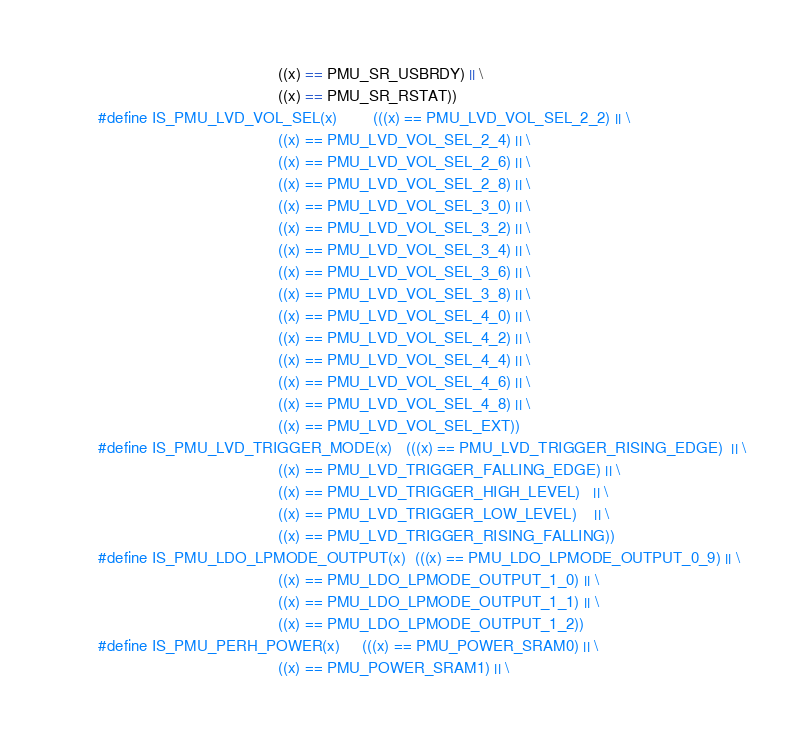Convert code to text. <code><loc_0><loc_0><loc_500><loc_500><_C_>                                         ((x) == PMU_SR_USBRDY) || \
                                         ((x) == PMU_SR_RSTAT))
#define IS_PMU_LVD_VOL_SEL(x)		(((x) == PMU_LVD_VOL_SEL_2_2) || \
                                         ((x) == PMU_LVD_VOL_SEL_2_4) || \
                                         ((x) == PMU_LVD_VOL_SEL_2_6) || \
                                         ((x) == PMU_LVD_VOL_SEL_2_8) || \
                                         ((x) == PMU_LVD_VOL_SEL_3_0) || \
                                         ((x) == PMU_LVD_VOL_SEL_3_2) || \
                                         ((x) == PMU_LVD_VOL_SEL_3_4) || \
                                         ((x) == PMU_LVD_VOL_SEL_3_6) || \
                                         ((x) == PMU_LVD_VOL_SEL_3_8) || \
                                         ((x) == PMU_LVD_VOL_SEL_4_0) || \
                                         ((x) == PMU_LVD_VOL_SEL_4_2) || \
                                         ((x) == PMU_LVD_VOL_SEL_4_4) || \
                                         ((x) == PMU_LVD_VOL_SEL_4_6) || \
                                         ((x) == PMU_LVD_VOL_SEL_4_8) || \
                                         ((x) == PMU_LVD_VOL_SEL_EXT))
#define IS_PMU_LVD_TRIGGER_MODE(x)	(((x) == PMU_LVD_TRIGGER_RISING_EDGE)  || \
                                         ((x) == PMU_LVD_TRIGGER_FALLING_EDGE) || \
                                         ((x) == PMU_LVD_TRIGGER_HIGH_LEVEL)   || \
                                         ((x) == PMU_LVD_TRIGGER_LOW_LEVEL)    || \
                                         ((x) == PMU_LVD_TRIGGER_RISING_FALLING))
#define IS_PMU_LDO_LPMODE_OUTPUT(x)	(((x) == PMU_LDO_LPMODE_OUTPUT_0_9) || \
                                         ((x) == PMU_LDO_LPMODE_OUTPUT_1_0) || \
                                         ((x) == PMU_LDO_LPMODE_OUTPUT_1_1) || \
                                         ((x) == PMU_LDO_LPMODE_OUTPUT_1_2))
#define IS_PMU_PERH_POWER(x)		(((x) == PMU_POWER_SRAM0) || \
                                         ((x) == PMU_POWER_SRAM1) || \</code> 